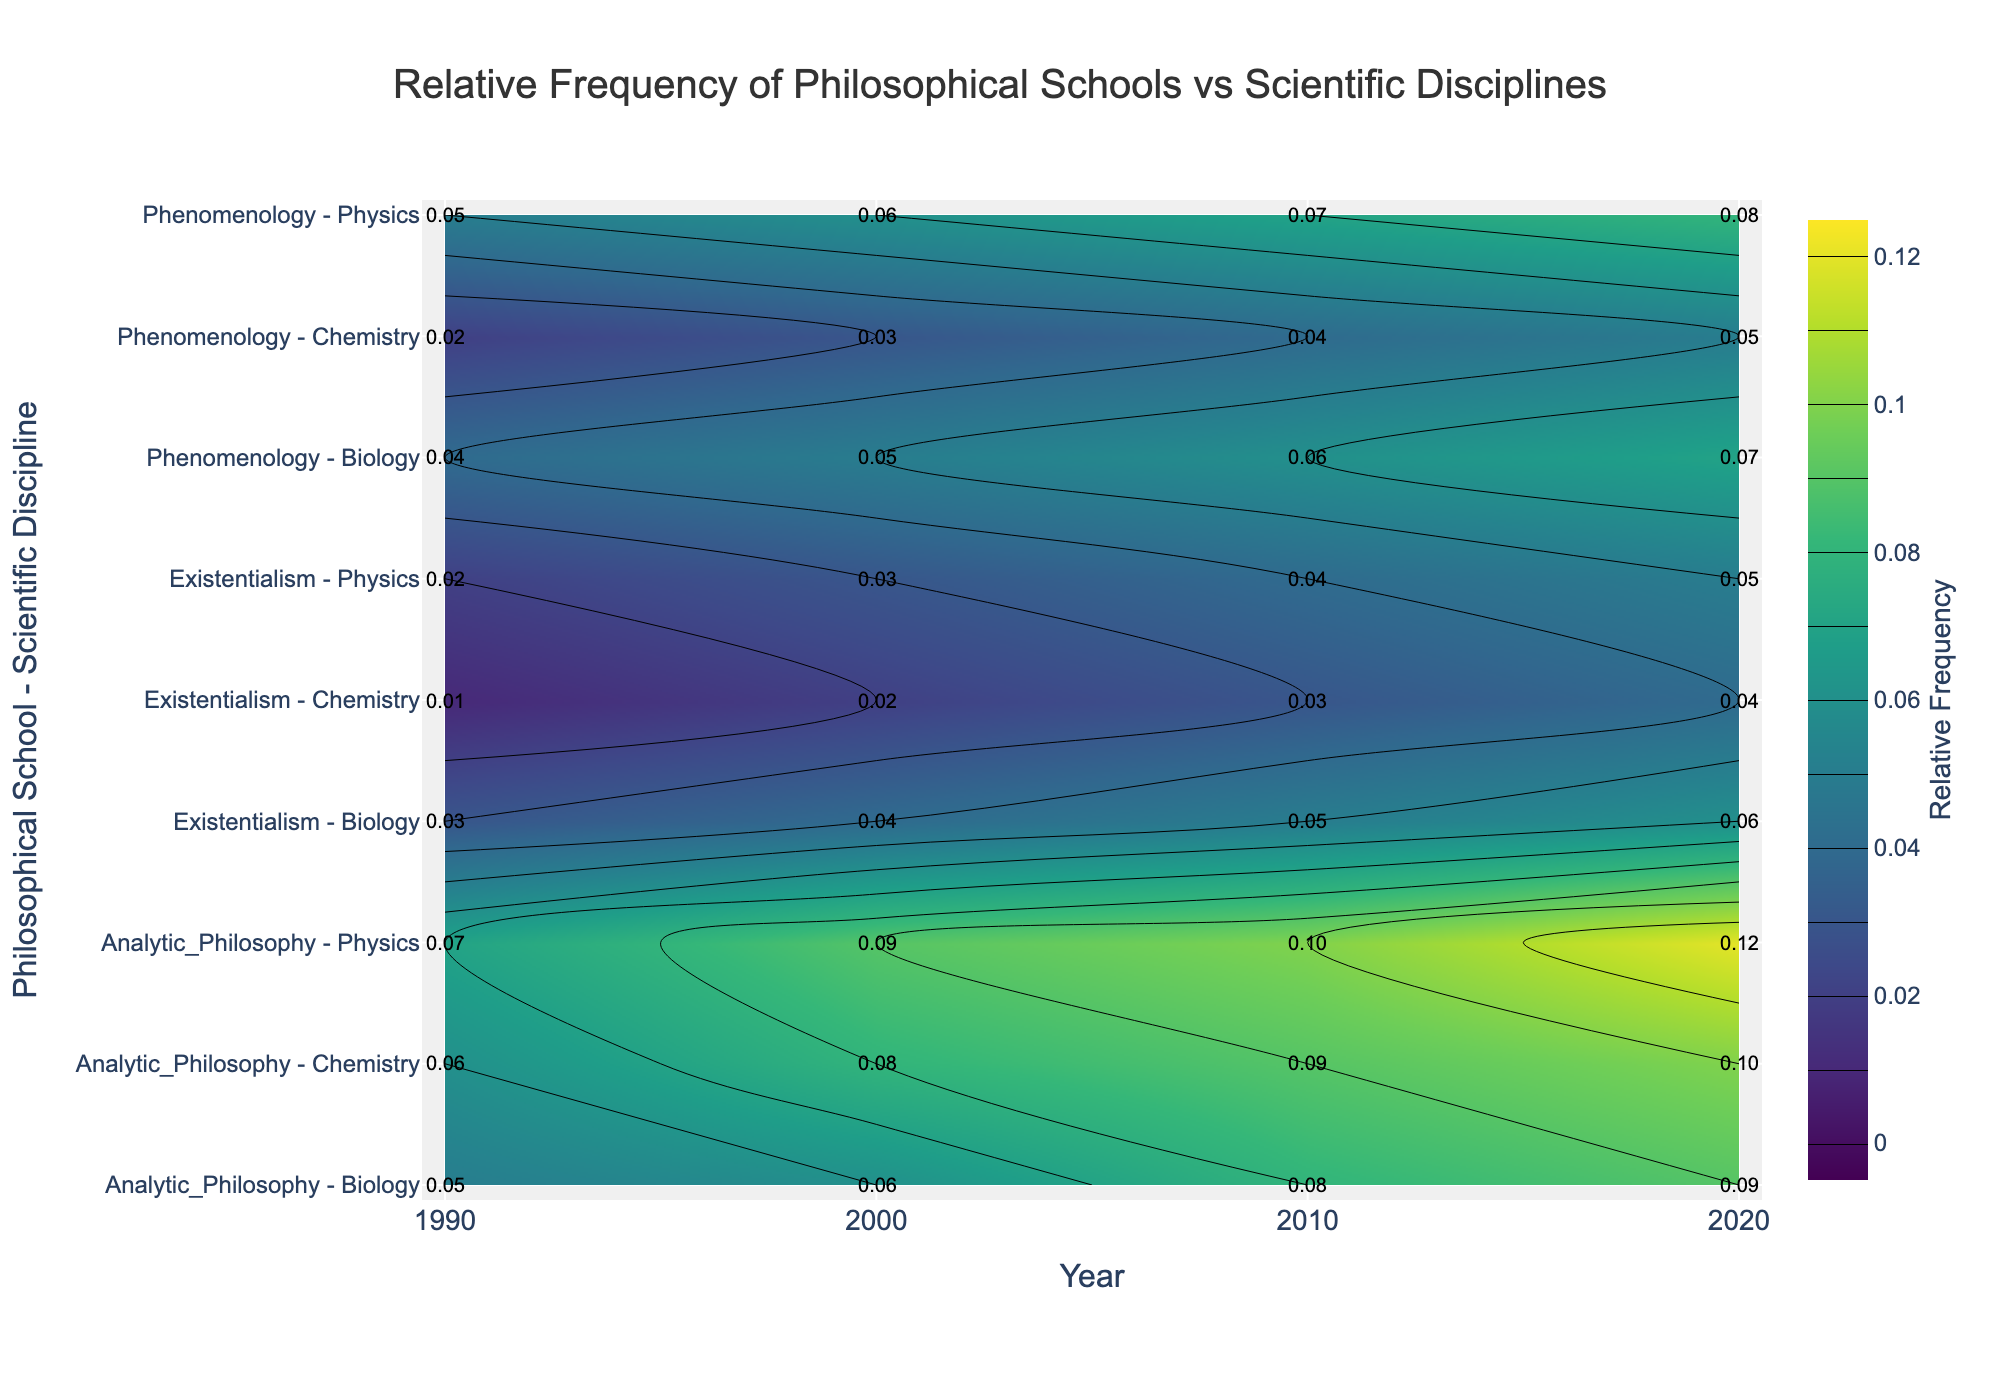What is the title of the figure? The title of the figure is prominently displayed at the top. It reads "Relative Frequency of Philosophical Schools vs Scientific Disciplines".
Answer: Relative Frequency of Philosophical Schools vs Scientific Disciplines What does the color bar on the right side of the plot represent? The color bar represents the relative frequency of philosophical schools vs scientific disciplines, with the values ranging from 0 to 0.12. The title "Relative Frequency" is indicated on the color bar, making it clear what metric is being measured.
Answer: Relative Frequency Which philosophical school and scientific discipline combination had the highest relative frequency in 2020? To determine the highest relative frequency for the year 2020, we look for the combination with the darkest color shade in that year's column on the figure. The annotation value for "Analytic Philosophy - Physics" in 2020 is 0.12, which is the highest.
Answer: Analytic Philosophy - Physics How did the relative frequency of Phenomenology in Biology change from 1990 to 2020? To observe the change, track the annotated values for "Phenomenology - Biology" over the years 1990 to 2020. In 1990: 0.04, 2000: 0.05, 2010: 0.06, and 2020: 0.07. Thus, the relative frequency increased gradually over these years.
Answer: Increased Compare the relative frequency of Existentialism in Physics and Chemistry in 2000. Check the annotated values for both combinations in the year 2000. For "Existentialism - Physics": 0.03, and for "Existentialism - Chemistry": 0.02. Clearly, the relative frequency in Physics is higher.
Answer: Higher in Physics Which year and combination show the lowest relative frequency on the entire plot? Look for the lightest shade in the entire figure, and identify its annotation. The value 0.01 corresponds to "Existentialism - Chemistry" in 1990.
Answer: 1990, Existentialism - Chemistry What trend is observed in the relative frequency of Analytic Philosophy in Physics over time? Analyzing the annotated values for "Analytic Philosophy - Physics" across each year, we see an increasing trend: 1990 (0.07), 2000 (0.09), 2010 (0.1), and 2020 (0.12).
Answer: Increasing Which philosophical school has the highest average relative frequency across all scientific disciplines in 2010? Calculate the average relative frequency for each school across all disciplines by summing and dividing by the number of disciplines: 
- Existentialism: (0.04+0.05+0.03)/3 = 0.04
- Phenomenology: (0.07+0.06+0.04)/3 = 0.056
- Analytic Philosophy: (0.1+0.08+0.09)/3 = 0.09
Analytic Philosophy has the highest average in 2010.
Answer: Analytic Philosophy Compare the relative frequency of Phenomenology in Chemistry to the average relative frequency of Existentialism in all disciplines in 2010. Find the value for "Phenomenology - Chemistry" in 2010, which is 0.04. Calculate the average for "Existentialism" across all disciplines for 2010: (0.04+0.05+0.03)/3 = 0.04. Both values are equal.
Answer: Equal What is the relative frequency of the combination "Phenomenology - Physics" in 2000 and how does it compare to "Analytic Philosophy - Chemistry" in the same year? Check the relative frequency annotation for "Phenomenology - Physics" in 2000 which is 0.06. Similarly, check for "Analytic Philosophy - Chemistry" which is 0.08. Phenomenology in Physics has a lower value.
Answer: 0.06, Lower 